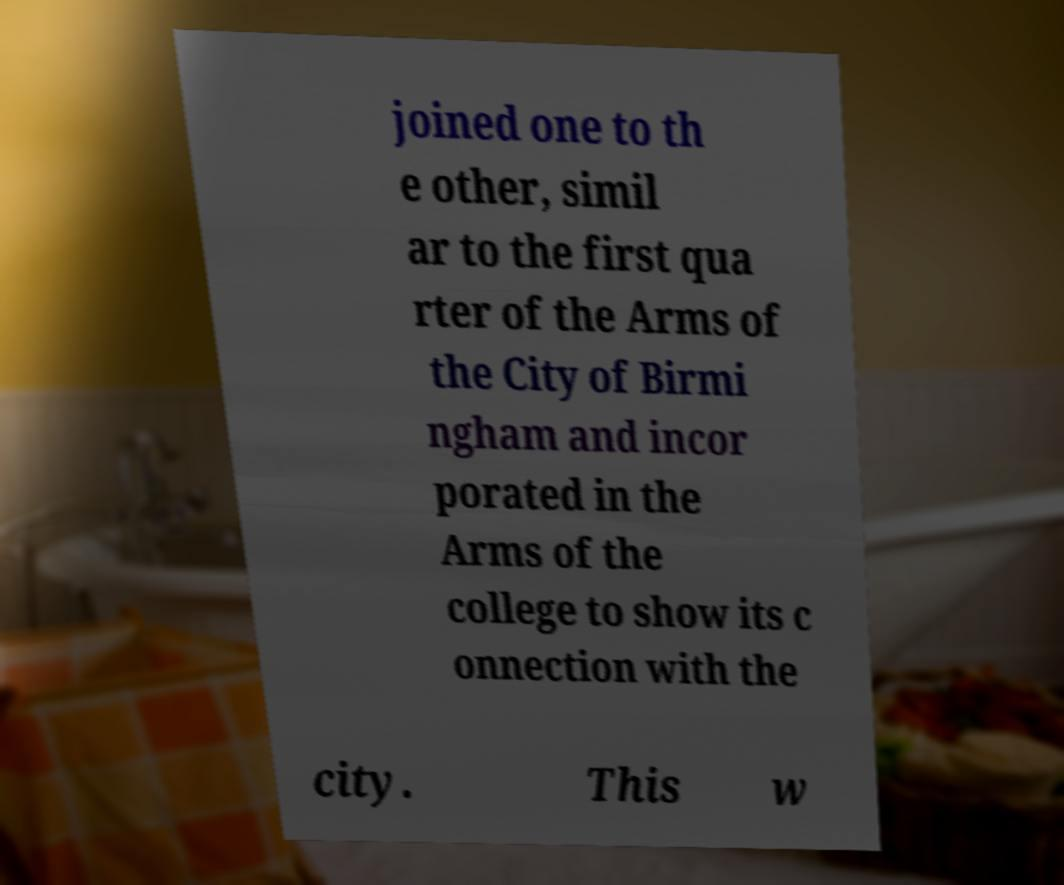Can you accurately transcribe the text from the provided image for me? joined one to th e other, simil ar to the first qua rter of the Arms of the City of Birmi ngham and incor porated in the Arms of the college to show its c onnection with the city. This w 